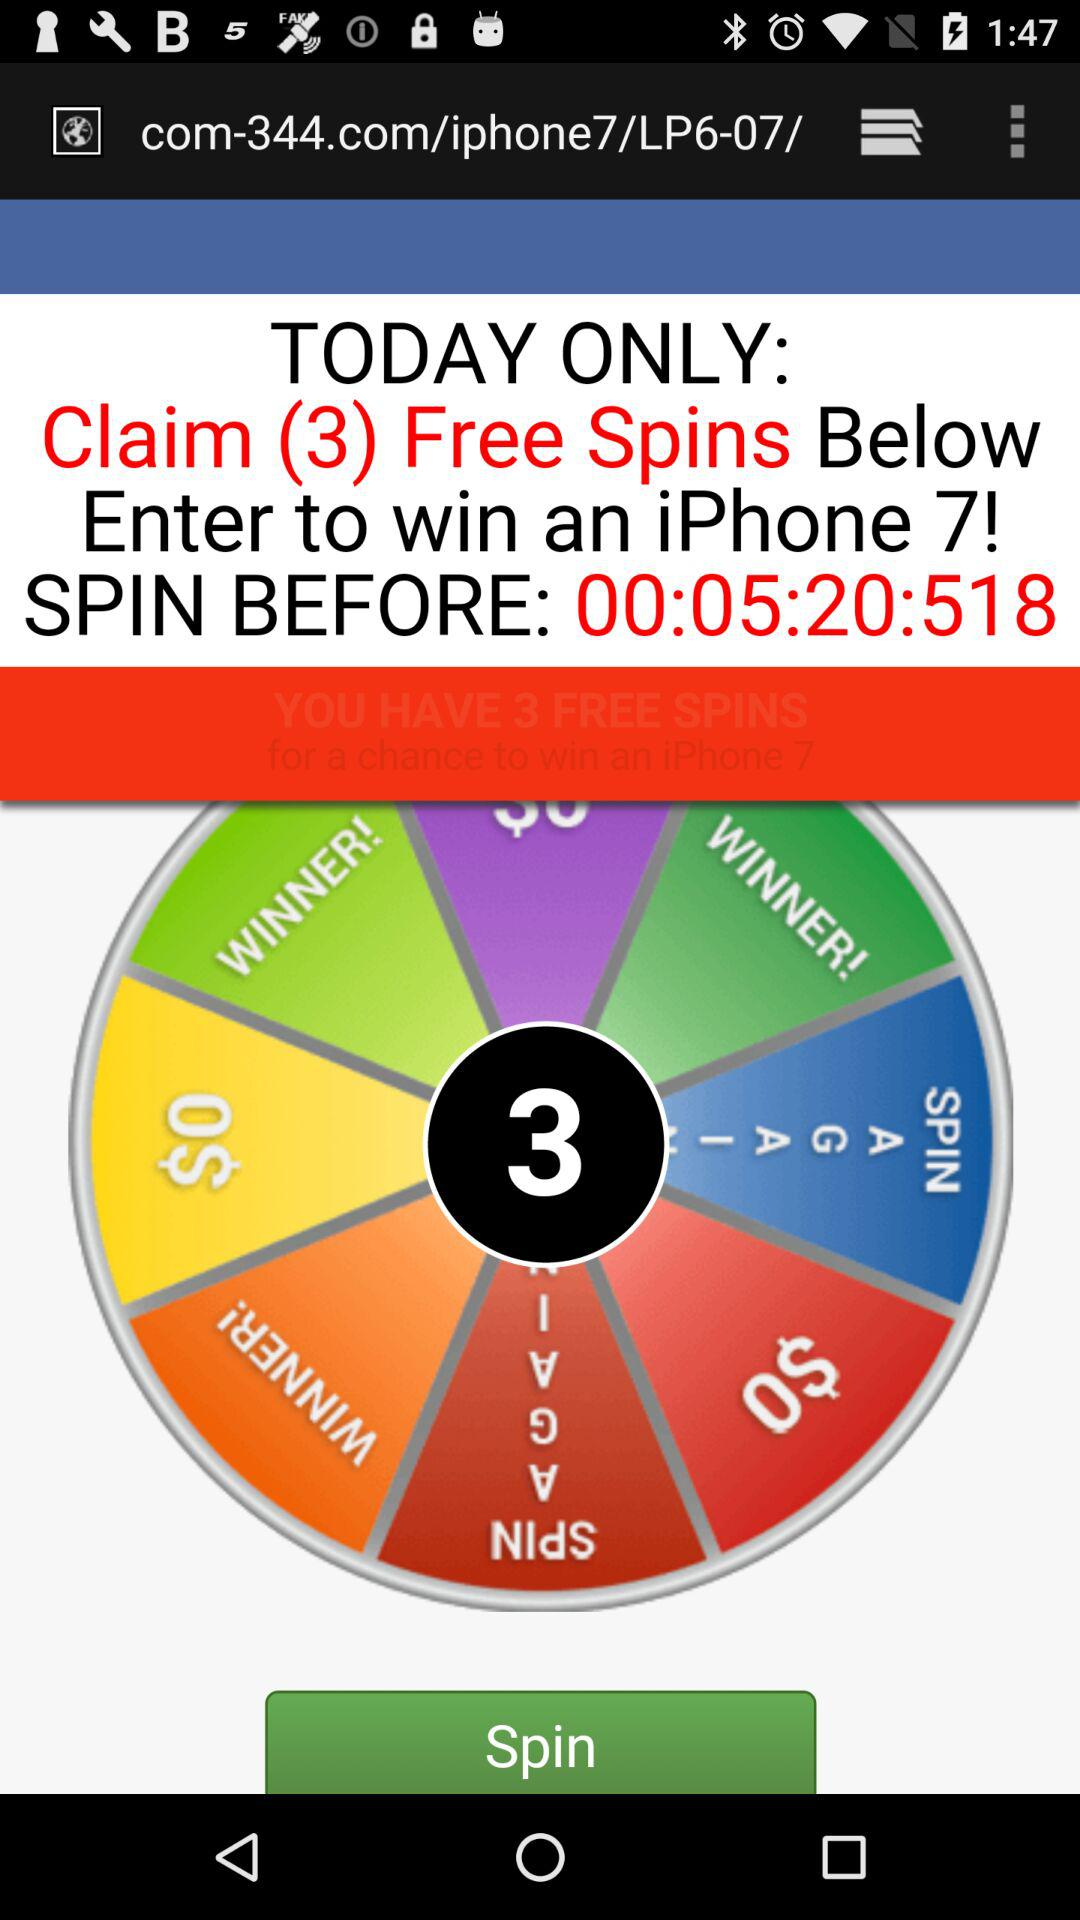What are the chances of winning from the spin wheel shown in the image? The chances of winning can vary based on how the game is programmed. Typically, promotional spin-to-win games like the one shown have lower probabilities for high-value prizes such as an iPhone, and higher probabilities for smaller rewards or additional spins. 